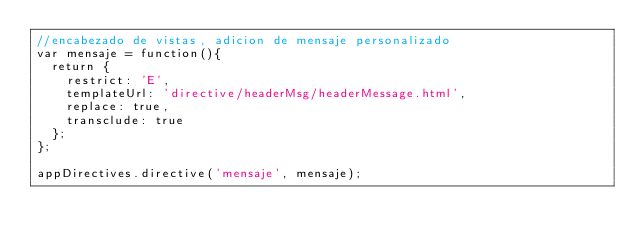Convert code to text. <code><loc_0><loc_0><loc_500><loc_500><_JavaScript_>//encabezado de vistas, adicion de mensaje personalizado
var mensaje = function(){
	return {
		restrict: 'E',
		templateUrl: 'directive/headerMsg/headerMessage.html',
		replace: true,
		transclude: true
	};
};

appDirectives.directive('mensaje', mensaje);
</code> 